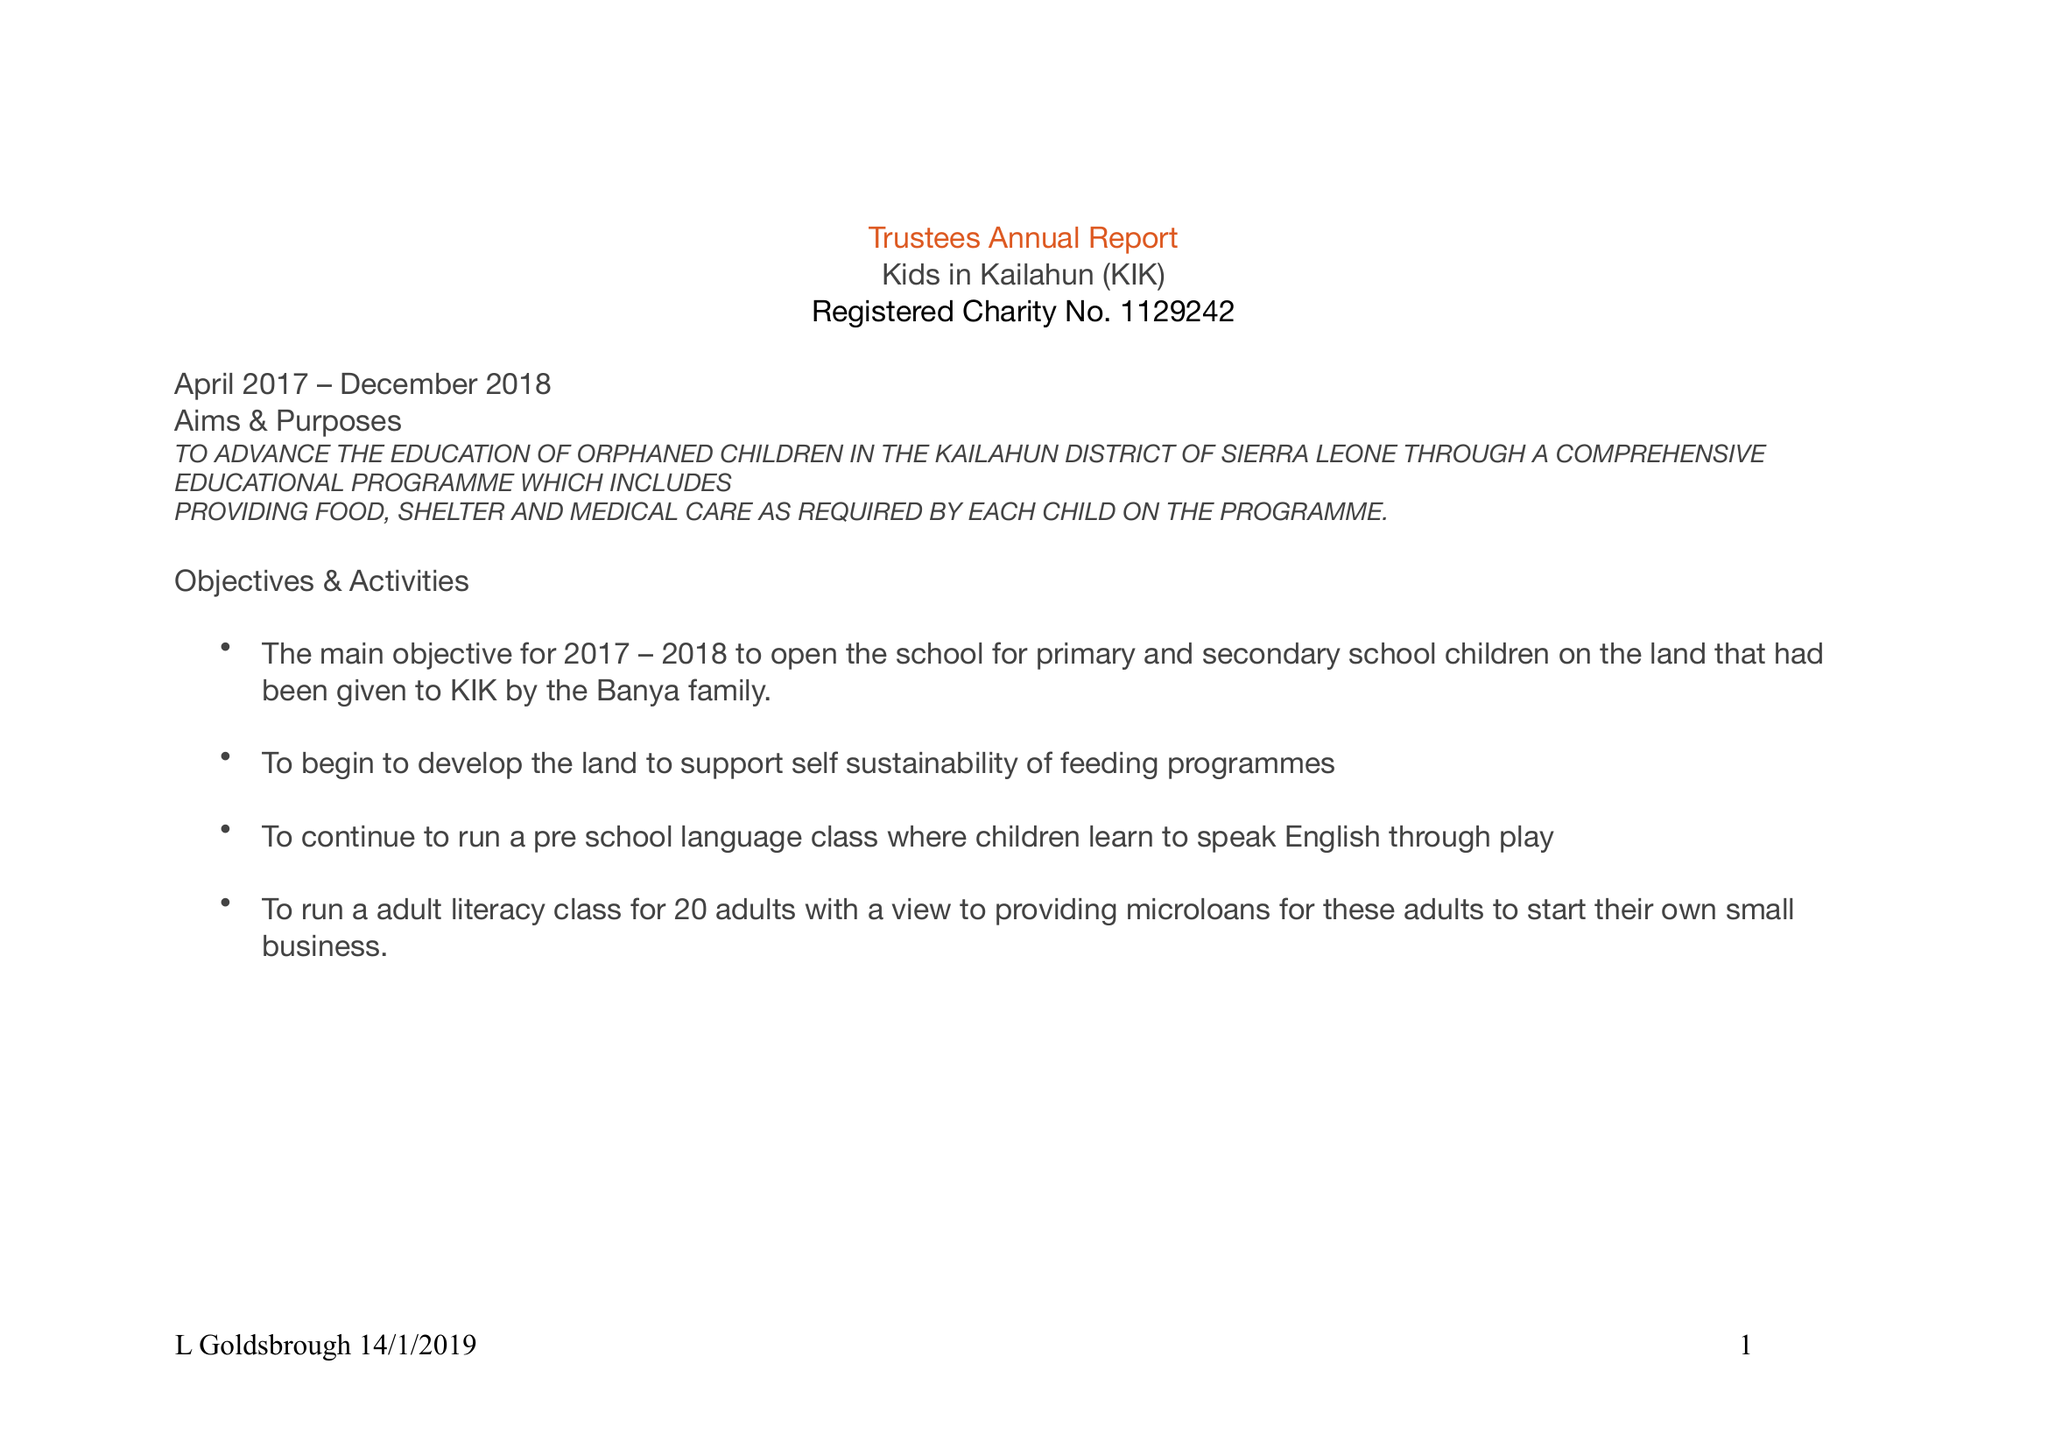What is the value for the address__postcode?
Answer the question using a single word or phrase. BB12 9LA 